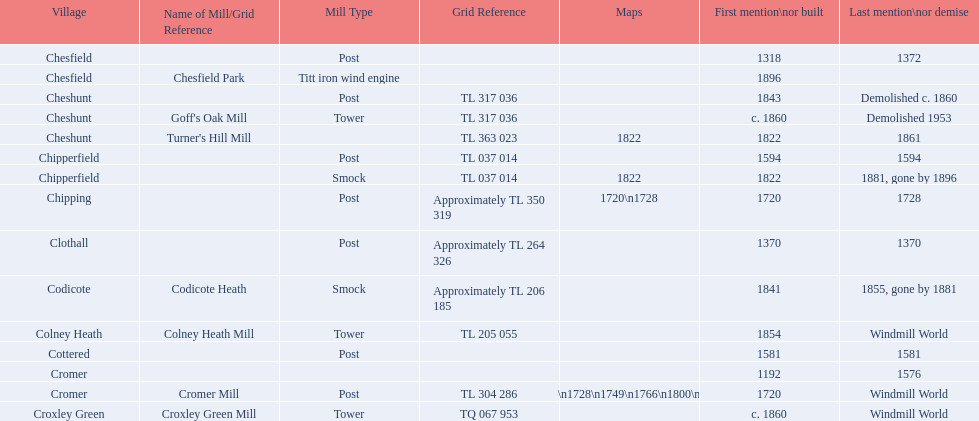How many mills were built or first mentioned after 1800? 8. 